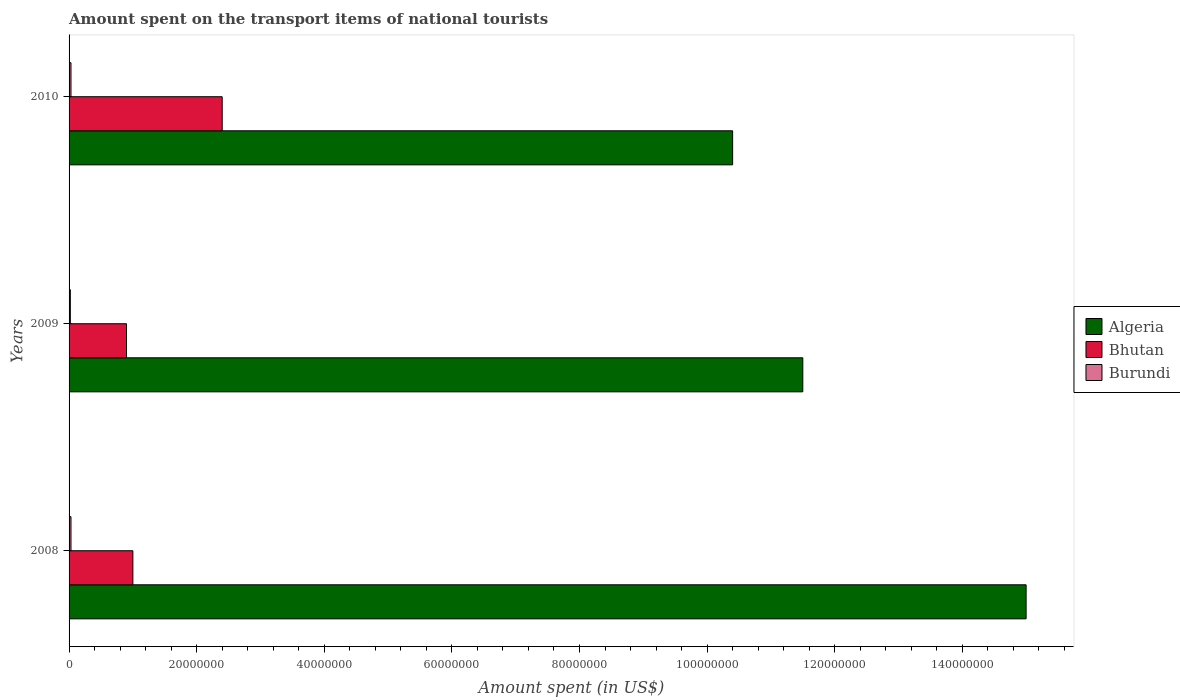How many groups of bars are there?
Your answer should be compact. 3. Are the number of bars on each tick of the Y-axis equal?
Your answer should be very brief. Yes. How many bars are there on the 3rd tick from the top?
Your response must be concise. 3. How many bars are there on the 1st tick from the bottom?
Keep it short and to the point. 3. What is the label of the 1st group of bars from the top?
Keep it short and to the point. 2010. In how many cases, is the number of bars for a given year not equal to the number of legend labels?
Offer a terse response. 0. Across all years, what is the maximum amount spent on the transport items of national tourists in Bhutan?
Your answer should be compact. 2.40e+07. Across all years, what is the minimum amount spent on the transport items of national tourists in Burundi?
Keep it short and to the point. 2.00e+05. What is the difference between the amount spent on the transport items of national tourists in Algeria in 2008 and that in 2010?
Keep it short and to the point. 4.60e+07. What is the difference between the amount spent on the transport items of national tourists in Algeria in 2010 and the amount spent on the transport items of national tourists in Burundi in 2009?
Provide a succinct answer. 1.04e+08. What is the average amount spent on the transport items of national tourists in Algeria per year?
Offer a terse response. 1.23e+08. In the year 2009, what is the difference between the amount spent on the transport items of national tourists in Burundi and amount spent on the transport items of national tourists in Algeria?
Keep it short and to the point. -1.15e+08. In how many years, is the amount spent on the transport items of national tourists in Algeria greater than 20000000 US$?
Make the answer very short. 3. What is the ratio of the amount spent on the transport items of national tourists in Bhutan in 2009 to that in 2010?
Your response must be concise. 0.38. Is the amount spent on the transport items of national tourists in Bhutan in 2008 less than that in 2009?
Your answer should be compact. No. What is the difference between the highest and the lowest amount spent on the transport items of national tourists in Algeria?
Your answer should be very brief. 4.60e+07. What does the 2nd bar from the top in 2009 represents?
Ensure brevity in your answer.  Bhutan. What does the 2nd bar from the bottom in 2008 represents?
Ensure brevity in your answer.  Bhutan. How many bars are there?
Make the answer very short. 9. Are all the bars in the graph horizontal?
Provide a succinct answer. Yes. Where does the legend appear in the graph?
Your answer should be very brief. Center right. How many legend labels are there?
Offer a terse response. 3. What is the title of the graph?
Ensure brevity in your answer.  Amount spent on the transport items of national tourists. What is the label or title of the X-axis?
Your answer should be compact. Amount spent (in US$). What is the label or title of the Y-axis?
Offer a terse response. Years. What is the Amount spent (in US$) in Algeria in 2008?
Your response must be concise. 1.50e+08. What is the Amount spent (in US$) in Burundi in 2008?
Provide a short and direct response. 3.00e+05. What is the Amount spent (in US$) in Algeria in 2009?
Give a very brief answer. 1.15e+08. What is the Amount spent (in US$) of Bhutan in 2009?
Your answer should be compact. 9.00e+06. What is the Amount spent (in US$) in Burundi in 2009?
Provide a short and direct response. 2.00e+05. What is the Amount spent (in US$) of Algeria in 2010?
Ensure brevity in your answer.  1.04e+08. What is the Amount spent (in US$) of Bhutan in 2010?
Your answer should be compact. 2.40e+07. What is the Amount spent (in US$) in Burundi in 2010?
Offer a very short reply. 3.00e+05. Across all years, what is the maximum Amount spent (in US$) of Algeria?
Provide a short and direct response. 1.50e+08. Across all years, what is the maximum Amount spent (in US$) of Bhutan?
Provide a succinct answer. 2.40e+07. Across all years, what is the maximum Amount spent (in US$) of Burundi?
Your response must be concise. 3.00e+05. Across all years, what is the minimum Amount spent (in US$) in Algeria?
Make the answer very short. 1.04e+08. Across all years, what is the minimum Amount spent (in US$) of Bhutan?
Your response must be concise. 9.00e+06. What is the total Amount spent (in US$) of Algeria in the graph?
Your answer should be very brief. 3.69e+08. What is the total Amount spent (in US$) in Bhutan in the graph?
Provide a succinct answer. 4.30e+07. What is the total Amount spent (in US$) in Burundi in the graph?
Offer a terse response. 8.00e+05. What is the difference between the Amount spent (in US$) in Algeria in 2008 and that in 2009?
Provide a short and direct response. 3.50e+07. What is the difference between the Amount spent (in US$) of Burundi in 2008 and that in 2009?
Ensure brevity in your answer.  1.00e+05. What is the difference between the Amount spent (in US$) in Algeria in 2008 and that in 2010?
Give a very brief answer. 4.60e+07. What is the difference between the Amount spent (in US$) in Bhutan in 2008 and that in 2010?
Make the answer very short. -1.40e+07. What is the difference between the Amount spent (in US$) of Burundi in 2008 and that in 2010?
Provide a succinct answer. 0. What is the difference between the Amount spent (in US$) in Algeria in 2009 and that in 2010?
Your answer should be compact. 1.10e+07. What is the difference between the Amount spent (in US$) of Bhutan in 2009 and that in 2010?
Your response must be concise. -1.50e+07. What is the difference between the Amount spent (in US$) of Burundi in 2009 and that in 2010?
Keep it short and to the point. -1.00e+05. What is the difference between the Amount spent (in US$) of Algeria in 2008 and the Amount spent (in US$) of Bhutan in 2009?
Provide a short and direct response. 1.41e+08. What is the difference between the Amount spent (in US$) in Algeria in 2008 and the Amount spent (in US$) in Burundi in 2009?
Your answer should be compact. 1.50e+08. What is the difference between the Amount spent (in US$) in Bhutan in 2008 and the Amount spent (in US$) in Burundi in 2009?
Make the answer very short. 9.80e+06. What is the difference between the Amount spent (in US$) in Algeria in 2008 and the Amount spent (in US$) in Bhutan in 2010?
Your answer should be very brief. 1.26e+08. What is the difference between the Amount spent (in US$) in Algeria in 2008 and the Amount spent (in US$) in Burundi in 2010?
Give a very brief answer. 1.50e+08. What is the difference between the Amount spent (in US$) in Bhutan in 2008 and the Amount spent (in US$) in Burundi in 2010?
Provide a short and direct response. 9.70e+06. What is the difference between the Amount spent (in US$) in Algeria in 2009 and the Amount spent (in US$) in Bhutan in 2010?
Give a very brief answer. 9.10e+07. What is the difference between the Amount spent (in US$) of Algeria in 2009 and the Amount spent (in US$) of Burundi in 2010?
Offer a terse response. 1.15e+08. What is the difference between the Amount spent (in US$) of Bhutan in 2009 and the Amount spent (in US$) of Burundi in 2010?
Keep it short and to the point. 8.70e+06. What is the average Amount spent (in US$) of Algeria per year?
Your answer should be very brief. 1.23e+08. What is the average Amount spent (in US$) in Bhutan per year?
Your response must be concise. 1.43e+07. What is the average Amount spent (in US$) in Burundi per year?
Offer a very short reply. 2.67e+05. In the year 2008, what is the difference between the Amount spent (in US$) in Algeria and Amount spent (in US$) in Bhutan?
Provide a succinct answer. 1.40e+08. In the year 2008, what is the difference between the Amount spent (in US$) in Algeria and Amount spent (in US$) in Burundi?
Offer a terse response. 1.50e+08. In the year 2008, what is the difference between the Amount spent (in US$) of Bhutan and Amount spent (in US$) of Burundi?
Your response must be concise. 9.70e+06. In the year 2009, what is the difference between the Amount spent (in US$) in Algeria and Amount spent (in US$) in Bhutan?
Your response must be concise. 1.06e+08. In the year 2009, what is the difference between the Amount spent (in US$) of Algeria and Amount spent (in US$) of Burundi?
Provide a succinct answer. 1.15e+08. In the year 2009, what is the difference between the Amount spent (in US$) in Bhutan and Amount spent (in US$) in Burundi?
Ensure brevity in your answer.  8.80e+06. In the year 2010, what is the difference between the Amount spent (in US$) in Algeria and Amount spent (in US$) in Bhutan?
Your response must be concise. 8.00e+07. In the year 2010, what is the difference between the Amount spent (in US$) of Algeria and Amount spent (in US$) of Burundi?
Offer a terse response. 1.04e+08. In the year 2010, what is the difference between the Amount spent (in US$) of Bhutan and Amount spent (in US$) of Burundi?
Your answer should be compact. 2.37e+07. What is the ratio of the Amount spent (in US$) of Algeria in 2008 to that in 2009?
Provide a short and direct response. 1.3. What is the ratio of the Amount spent (in US$) in Burundi in 2008 to that in 2009?
Keep it short and to the point. 1.5. What is the ratio of the Amount spent (in US$) in Algeria in 2008 to that in 2010?
Make the answer very short. 1.44. What is the ratio of the Amount spent (in US$) of Bhutan in 2008 to that in 2010?
Offer a terse response. 0.42. What is the ratio of the Amount spent (in US$) in Burundi in 2008 to that in 2010?
Your answer should be compact. 1. What is the ratio of the Amount spent (in US$) in Algeria in 2009 to that in 2010?
Keep it short and to the point. 1.11. What is the ratio of the Amount spent (in US$) of Bhutan in 2009 to that in 2010?
Provide a short and direct response. 0.38. What is the ratio of the Amount spent (in US$) in Burundi in 2009 to that in 2010?
Make the answer very short. 0.67. What is the difference between the highest and the second highest Amount spent (in US$) in Algeria?
Your answer should be compact. 3.50e+07. What is the difference between the highest and the second highest Amount spent (in US$) of Bhutan?
Offer a terse response. 1.40e+07. What is the difference between the highest and the lowest Amount spent (in US$) in Algeria?
Your response must be concise. 4.60e+07. What is the difference between the highest and the lowest Amount spent (in US$) of Bhutan?
Provide a short and direct response. 1.50e+07. 